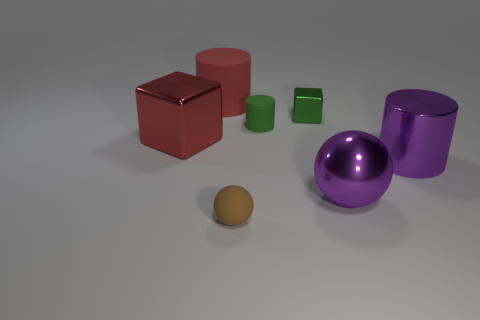How many big purple metallic objects have the same shape as the tiny brown rubber thing?
Give a very brief answer. 1. What number of objects are matte cylinders that are in front of the tiny metallic object or things behind the large purple ball?
Offer a terse response. 5. What number of red objects are cylinders or rubber objects?
Provide a short and direct response. 1. There is a cylinder that is both left of the shiny sphere and in front of the tiny metallic cube; what material is it?
Provide a short and direct response. Rubber. Does the big purple cylinder have the same material as the purple sphere?
Your response must be concise. Yes. What number of purple metal spheres have the same size as the green rubber object?
Keep it short and to the point. 0. Are there an equal number of red metal things that are to the right of the small metallic thing and tiny brown balls?
Make the answer very short. No. How many objects are both right of the brown thing and behind the big metal cylinder?
Provide a succinct answer. 2. There is a tiny thing in front of the large red metal block; is its shape the same as the red shiny object?
Give a very brief answer. No. There is a green block that is the same size as the brown sphere; what material is it?
Make the answer very short. Metal. 